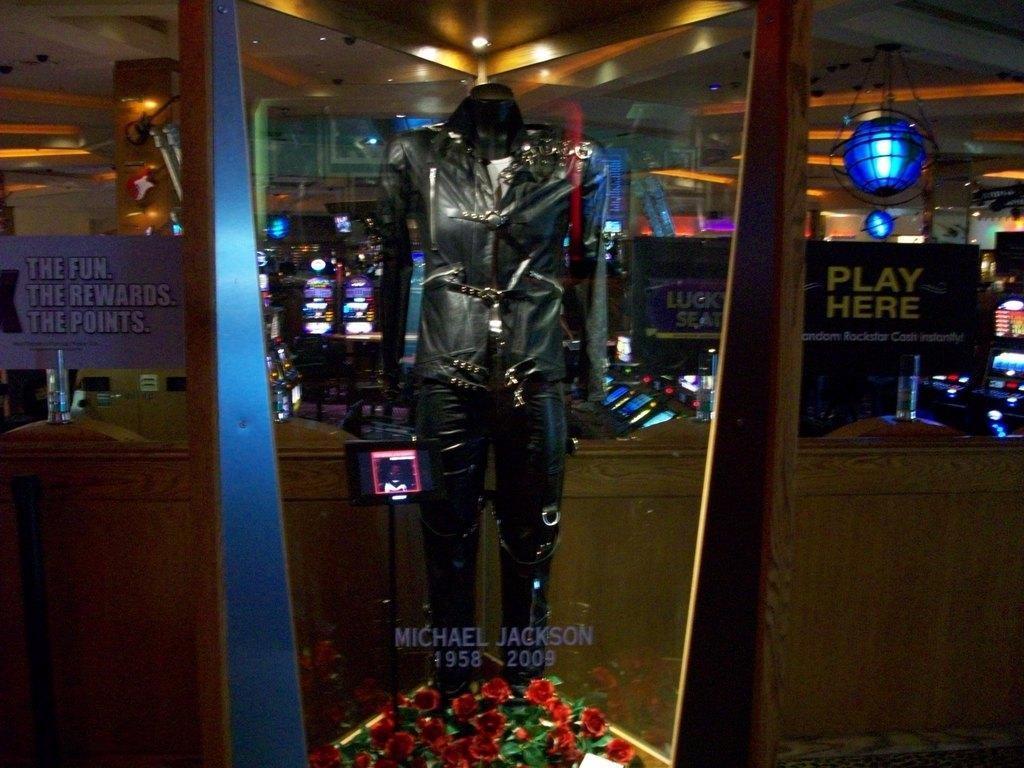What is the main object in the image? There is a mannequin in the image. What else can be seen in the image besides the mannequin? There is a pole, screens, glass with text, posters, lights, a pillar, and other objects in the image. Can you describe the pole in the image? There is a pole in the image, but no further details are provided about its appearance or function. What is written on the glass in the image? The text on the glass in the image is not specified. How does the boy feel about his uncle's desire to visit the location depicted in the image? There is no boy or uncle mentioned in the image, nor any indication of their feelings or desires. 